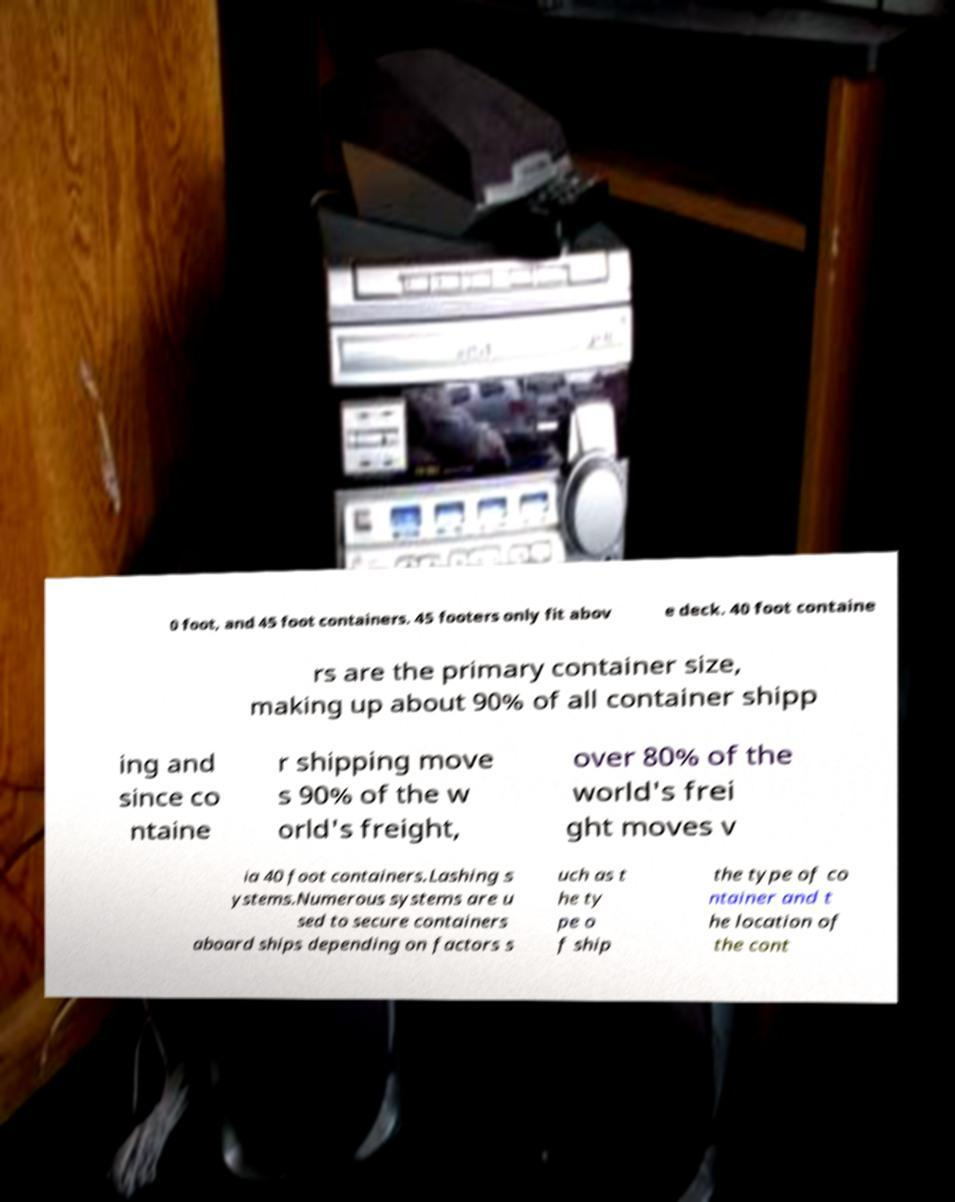What messages or text are displayed in this image? I need them in a readable, typed format. 0 foot, and 45 foot containers. 45 footers only fit abov e deck. 40 foot containe rs are the primary container size, making up about 90% of all container shipp ing and since co ntaine r shipping move s 90% of the w orld's freight, over 80% of the world's frei ght moves v ia 40 foot containers.Lashing s ystems.Numerous systems are u sed to secure containers aboard ships depending on factors s uch as t he ty pe o f ship the type of co ntainer and t he location of the cont 